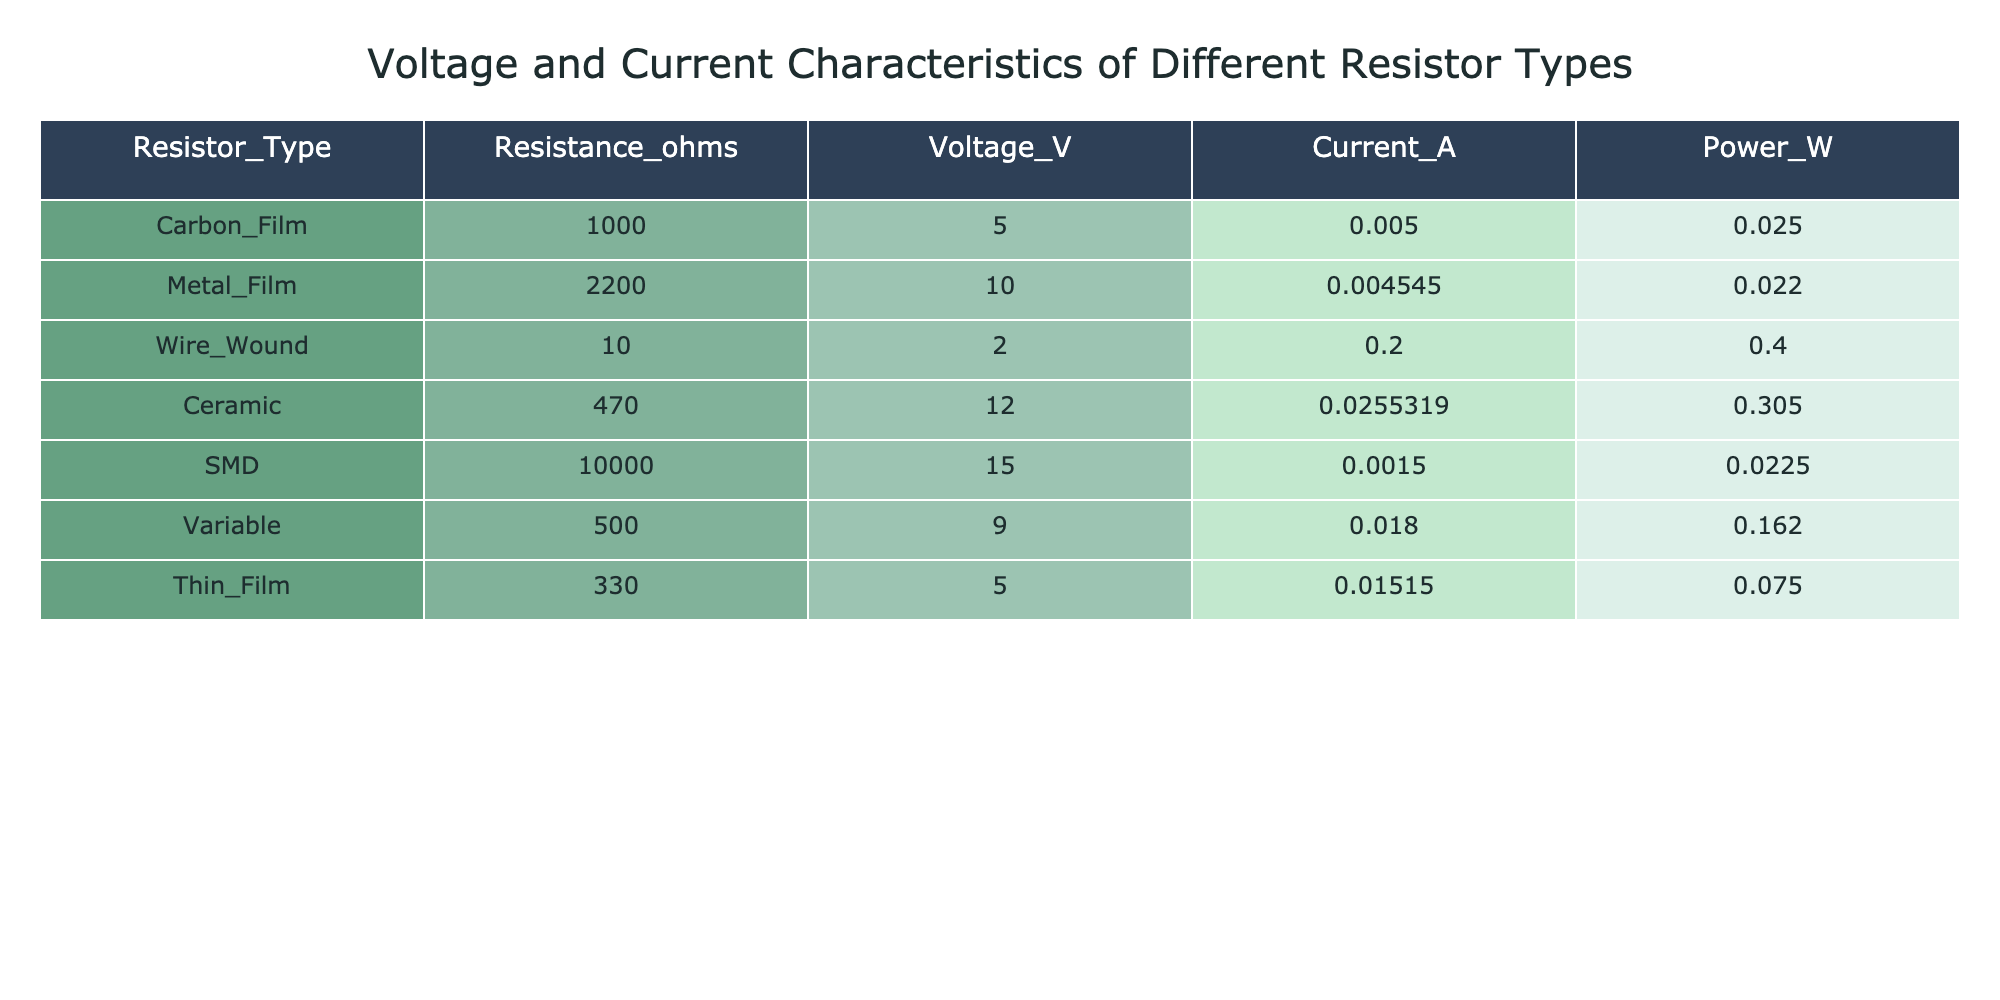What is the resistance value of the Wire Wound resistor? Referring to the table, the Wire Wound resistor has a resistance value listed as 10 ohms.
Answer: 10 ohms What is the current flowing through the Ceramic resistor? The table specifies that the current through the Ceramic resistor is 0.0255319 A.
Answer: 0.0255319 A Which resistor type has the highest voltage rating? By comparing the voltage values in the table, the SMD resistor has the highest voltage rating at 15 V.
Answer: 15 V What is the total power consumed by the Carbon Film and Metal Film resistors combined? The power consumed by the Carbon Film resistor is 0.025 W and by the Metal Film resistor is 0.022 W. Adding these gives 0.025 + 0.022 = 0.047 W.
Answer: 0.047 W Is the current through the Variable resistor greater than the current through the SMD resistor? The current through the Variable resistor is 0.018 A, while the current through the SMD resistor is 0.0015 A. Since 0.018 > 0.0015, the statement is true.
Answer: Yes What is the average resistance value of all the resistors in the table? The resistance values are 1000, 2200, 10, 470, 10000, 500, and 330 ohms, summing them yields 1000 + 2200 + 10 + 470 + 10000 + 500 + 330 = 13970 ohms. There are 7 resistors, hence the average resistance = 13970 / 7 ≈ 1995.71 ohms.
Answer: 1995.71 ohms Which resistor type has the lowest power consumption? By reviewing the power values, the Metal Film resistor has a power consumption of 0.022 W, which is the lowest when compared to the others.
Answer: 0.022 W Is the current through the Thin Film resistor less than the current through the Wire Wound resistor? The current through the Thin Film resistor is 0.01515 A, and the current through the Wire Wound resistor is 0.2 A. Since 0.01515 < 0.2, the statement is true.
Answer: Yes How much greater is the voltage across the Ceramic resistor compared to the voltage across the Wire Wound resistor? The voltage across the Ceramic resistor is 12 V and the Wire Wound resistor's voltage is 2 V. The difference is 12 - 2 = 10 V.
Answer: 10 V 